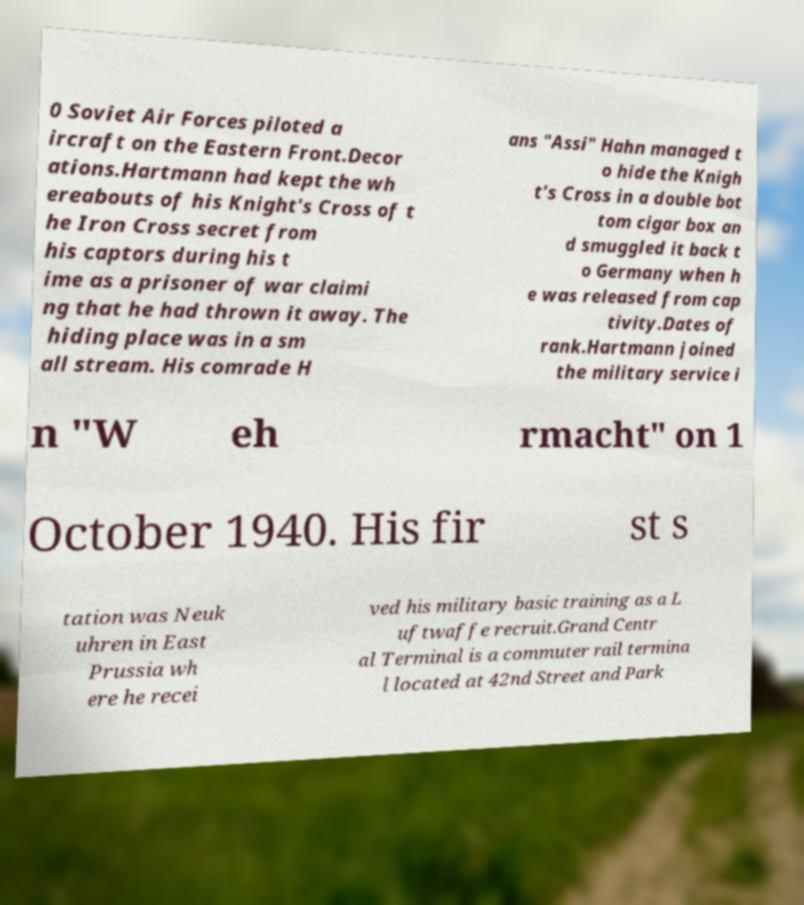I need the written content from this picture converted into text. Can you do that? 0 Soviet Air Forces piloted a ircraft on the Eastern Front.Decor ations.Hartmann had kept the wh ereabouts of his Knight's Cross of t he Iron Cross secret from his captors during his t ime as a prisoner of war claimi ng that he had thrown it away. The hiding place was in a sm all stream. His comrade H ans "Assi" Hahn managed t o hide the Knigh t's Cross in a double bot tom cigar box an d smuggled it back t o Germany when h e was released from cap tivity.Dates of rank.Hartmann joined the military service i n "W eh rmacht" on 1 October 1940. His fir st s tation was Neuk uhren in East Prussia wh ere he recei ved his military basic training as a L uftwaffe recruit.Grand Centr al Terminal is a commuter rail termina l located at 42nd Street and Park 